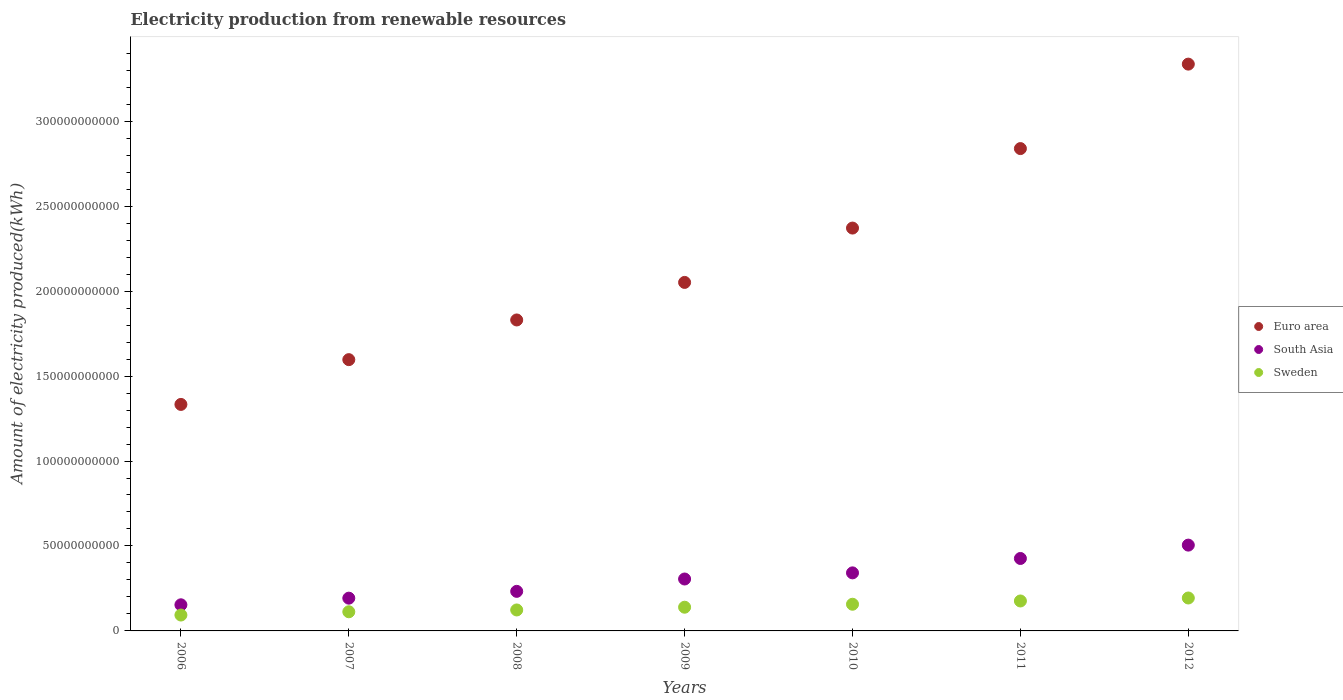How many different coloured dotlines are there?
Your answer should be very brief. 3. What is the amount of electricity produced in Sweden in 2007?
Keep it short and to the point. 1.13e+1. Across all years, what is the maximum amount of electricity produced in Sweden?
Your response must be concise. 1.94e+1. Across all years, what is the minimum amount of electricity produced in Euro area?
Keep it short and to the point. 1.33e+11. In which year was the amount of electricity produced in Euro area maximum?
Make the answer very short. 2012. What is the total amount of electricity produced in Sweden in the graph?
Provide a short and direct response. 9.96e+1. What is the difference between the amount of electricity produced in Sweden in 2009 and that in 2012?
Provide a short and direct response. -5.43e+09. What is the difference between the amount of electricity produced in South Asia in 2006 and the amount of electricity produced in Sweden in 2012?
Offer a very short reply. -4.00e+09. What is the average amount of electricity produced in Euro area per year?
Your answer should be very brief. 2.19e+11. In the year 2008, what is the difference between the amount of electricity produced in Euro area and amount of electricity produced in South Asia?
Offer a very short reply. 1.60e+11. In how many years, is the amount of electricity produced in Sweden greater than 30000000000 kWh?
Keep it short and to the point. 0. What is the ratio of the amount of electricity produced in South Asia in 2011 to that in 2012?
Offer a terse response. 0.84. Is the amount of electricity produced in South Asia in 2006 less than that in 2010?
Offer a very short reply. Yes. Is the difference between the amount of electricity produced in Euro area in 2008 and 2012 greater than the difference between the amount of electricity produced in South Asia in 2008 and 2012?
Keep it short and to the point. No. What is the difference between the highest and the second highest amount of electricity produced in Sweden?
Your answer should be very brief. 1.75e+09. What is the difference between the highest and the lowest amount of electricity produced in Euro area?
Provide a succinct answer. 2.00e+11. Is the sum of the amount of electricity produced in South Asia in 2010 and 2011 greater than the maximum amount of electricity produced in Euro area across all years?
Your answer should be compact. No. Is the amount of electricity produced in Sweden strictly less than the amount of electricity produced in South Asia over the years?
Ensure brevity in your answer.  Yes. How many years are there in the graph?
Your answer should be very brief. 7. What is the title of the graph?
Give a very brief answer. Electricity production from renewable resources. What is the label or title of the X-axis?
Your answer should be compact. Years. What is the label or title of the Y-axis?
Ensure brevity in your answer.  Amount of electricity produced(kWh). What is the Amount of electricity produced(kWh) of Euro area in 2006?
Give a very brief answer. 1.33e+11. What is the Amount of electricity produced(kWh) in South Asia in 2006?
Provide a succinct answer. 1.54e+1. What is the Amount of electricity produced(kWh) in Sweden in 2006?
Offer a terse response. 9.35e+09. What is the Amount of electricity produced(kWh) of Euro area in 2007?
Ensure brevity in your answer.  1.60e+11. What is the Amount of electricity produced(kWh) of South Asia in 2007?
Provide a succinct answer. 1.93e+1. What is the Amount of electricity produced(kWh) of Sweden in 2007?
Your answer should be compact. 1.13e+1. What is the Amount of electricity produced(kWh) of Euro area in 2008?
Ensure brevity in your answer.  1.83e+11. What is the Amount of electricity produced(kWh) of South Asia in 2008?
Make the answer very short. 2.33e+1. What is the Amount of electricity produced(kWh) in Sweden in 2008?
Keep it short and to the point. 1.23e+1. What is the Amount of electricity produced(kWh) of Euro area in 2009?
Ensure brevity in your answer.  2.05e+11. What is the Amount of electricity produced(kWh) of South Asia in 2009?
Give a very brief answer. 3.06e+1. What is the Amount of electricity produced(kWh) of Sweden in 2009?
Your answer should be very brief. 1.40e+1. What is the Amount of electricity produced(kWh) in Euro area in 2010?
Your response must be concise. 2.37e+11. What is the Amount of electricity produced(kWh) of South Asia in 2010?
Provide a succinct answer. 3.42e+1. What is the Amount of electricity produced(kWh) in Sweden in 2010?
Provide a short and direct response. 1.57e+1. What is the Amount of electricity produced(kWh) in Euro area in 2011?
Give a very brief answer. 2.84e+11. What is the Amount of electricity produced(kWh) in South Asia in 2011?
Offer a terse response. 4.26e+1. What is the Amount of electricity produced(kWh) of Sweden in 2011?
Give a very brief answer. 1.76e+1. What is the Amount of electricity produced(kWh) of Euro area in 2012?
Offer a terse response. 3.34e+11. What is the Amount of electricity produced(kWh) in South Asia in 2012?
Your answer should be very brief. 5.05e+1. What is the Amount of electricity produced(kWh) of Sweden in 2012?
Your response must be concise. 1.94e+1. Across all years, what is the maximum Amount of electricity produced(kWh) of Euro area?
Provide a short and direct response. 3.34e+11. Across all years, what is the maximum Amount of electricity produced(kWh) of South Asia?
Ensure brevity in your answer.  5.05e+1. Across all years, what is the maximum Amount of electricity produced(kWh) in Sweden?
Your response must be concise. 1.94e+1. Across all years, what is the minimum Amount of electricity produced(kWh) of Euro area?
Your response must be concise. 1.33e+11. Across all years, what is the minimum Amount of electricity produced(kWh) of South Asia?
Provide a succinct answer. 1.54e+1. Across all years, what is the minimum Amount of electricity produced(kWh) in Sweden?
Offer a terse response. 9.35e+09. What is the total Amount of electricity produced(kWh) of Euro area in the graph?
Your answer should be very brief. 1.54e+12. What is the total Amount of electricity produced(kWh) in South Asia in the graph?
Offer a terse response. 2.16e+11. What is the total Amount of electricity produced(kWh) in Sweden in the graph?
Provide a succinct answer. 9.96e+1. What is the difference between the Amount of electricity produced(kWh) in Euro area in 2006 and that in 2007?
Provide a succinct answer. -2.64e+1. What is the difference between the Amount of electricity produced(kWh) of South Asia in 2006 and that in 2007?
Make the answer very short. -3.90e+09. What is the difference between the Amount of electricity produced(kWh) of Sweden in 2006 and that in 2007?
Your answer should be very brief. -1.92e+09. What is the difference between the Amount of electricity produced(kWh) of Euro area in 2006 and that in 2008?
Offer a terse response. -4.97e+1. What is the difference between the Amount of electricity produced(kWh) in South Asia in 2006 and that in 2008?
Give a very brief answer. -7.91e+09. What is the difference between the Amount of electricity produced(kWh) of Sweden in 2006 and that in 2008?
Offer a very short reply. -2.99e+09. What is the difference between the Amount of electricity produced(kWh) in Euro area in 2006 and that in 2009?
Offer a terse response. -7.18e+1. What is the difference between the Amount of electricity produced(kWh) of South Asia in 2006 and that in 2009?
Offer a very short reply. -1.52e+1. What is the difference between the Amount of electricity produced(kWh) in Sweden in 2006 and that in 2009?
Make the answer very short. -4.60e+09. What is the difference between the Amount of electricity produced(kWh) of Euro area in 2006 and that in 2010?
Give a very brief answer. -1.04e+11. What is the difference between the Amount of electricity produced(kWh) of South Asia in 2006 and that in 2010?
Your answer should be very brief. -1.88e+1. What is the difference between the Amount of electricity produced(kWh) in Sweden in 2006 and that in 2010?
Keep it short and to the point. -6.36e+09. What is the difference between the Amount of electricity produced(kWh) of Euro area in 2006 and that in 2011?
Keep it short and to the point. -1.51e+11. What is the difference between the Amount of electricity produced(kWh) of South Asia in 2006 and that in 2011?
Provide a short and direct response. -2.73e+1. What is the difference between the Amount of electricity produced(kWh) of Sweden in 2006 and that in 2011?
Your answer should be very brief. -8.28e+09. What is the difference between the Amount of electricity produced(kWh) of Euro area in 2006 and that in 2012?
Your answer should be compact. -2.00e+11. What is the difference between the Amount of electricity produced(kWh) of South Asia in 2006 and that in 2012?
Give a very brief answer. -3.51e+1. What is the difference between the Amount of electricity produced(kWh) of Sweden in 2006 and that in 2012?
Offer a very short reply. -1.00e+1. What is the difference between the Amount of electricity produced(kWh) of Euro area in 2007 and that in 2008?
Offer a very short reply. -2.34e+1. What is the difference between the Amount of electricity produced(kWh) in South Asia in 2007 and that in 2008?
Make the answer very short. -4.01e+09. What is the difference between the Amount of electricity produced(kWh) in Sweden in 2007 and that in 2008?
Your answer should be very brief. -1.07e+09. What is the difference between the Amount of electricity produced(kWh) of Euro area in 2007 and that in 2009?
Your answer should be compact. -4.55e+1. What is the difference between the Amount of electricity produced(kWh) of South Asia in 2007 and that in 2009?
Make the answer very short. -1.13e+1. What is the difference between the Amount of electricity produced(kWh) of Sweden in 2007 and that in 2009?
Give a very brief answer. -2.68e+09. What is the difference between the Amount of electricity produced(kWh) of Euro area in 2007 and that in 2010?
Keep it short and to the point. -7.74e+1. What is the difference between the Amount of electricity produced(kWh) in South Asia in 2007 and that in 2010?
Your response must be concise. -1.49e+1. What is the difference between the Amount of electricity produced(kWh) in Sweden in 2007 and that in 2010?
Offer a terse response. -4.43e+09. What is the difference between the Amount of electricity produced(kWh) of Euro area in 2007 and that in 2011?
Make the answer very short. -1.24e+11. What is the difference between the Amount of electricity produced(kWh) in South Asia in 2007 and that in 2011?
Ensure brevity in your answer.  -2.34e+1. What is the difference between the Amount of electricity produced(kWh) of Sweden in 2007 and that in 2011?
Give a very brief answer. -6.36e+09. What is the difference between the Amount of electricity produced(kWh) of Euro area in 2007 and that in 2012?
Ensure brevity in your answer.  -1.74e+11. What is the difference between the Amount of electricity produced(kWh) of South Asia in 2007 and that in 2012?
Provide a succinct answer. -3.12e+1. What is the difference between the Amount of electricity produced(kWh) of Sweden in 2007 and that in 2012?
Make the answer very short. -8.11e+09. What is the difference between the Amount of electricity produced(kWh) in Euro area in 2008 and that in 2009?
Your answer should be very brief. -2.21e+1. What is the difference between the Amount of electricity produced(kWh) of South Asia in 2008 and that in 2009?
Ensure brevity in your answer.  -7.27e+09. What is the difference between the Amount of electricity produced(kWh) of Sweden in 2008 and that in 2009?
Ensure brevity in your answer.  -1.62e+09. What is the difference between the Amount of electricity produced(kWh) in Euro area in 2008 and that in 2010?
Offer a very short reply. -5.41e+1. What is the difference between the Amount of electricity produced(kWh) in South Asia in 2008 and that in 2010?
Ensure brevity in your answer.  -1.09e+1. What is the difference between the Amount of electricity produced(kWh) in Sweden in 2008 and that in 2010?
Make the answer very short. -3.37e+09. What is the difference between the Amount of electricity produced(kWh) of Euro area in 2008 and that in 2011?
Offer a very short reply. -1.01e+11. What is the difference between the Amount of electricity produced(kWh) in South Asia in 2008 and that in 2011?
Your answer should be very brief. -1.94e+1. What is the difference between the Amount of electricity produced(kWh) of Sweden in 2008 and that in 2011?
Offer a terse response. -5.29e+09. What is the difference between the Amount of electricity produced(kWh) in Euro area in 2008 and that in 2012?
Make the answer very short. -1.51e+11. What is the difference between the Amount of electricity produced(kWh) in South Asia in 2008 and that in 2012?
Give a very brief answer. -2.72e+1. What is the difference between the Amount of electricity produced(kWh) of Sweden in 2008 and that in 2012?
Provide a succinct answer. -7.04e+09. What is the difference between the Amount of electricity produced(kWh) of Euro area in 2009 and that in 2010?
Provide a short and direct response. -3.20e+1. What is the difference between the Amount of electricity produced(kWh) of South Asia in 2009 and that in 2010?
Provide a succinct answer. -3.61e+09. What is the difference between the Amount of electricity produced(kWh) of Sweden in 2009 and that in 2010?
Offer a very short reply. -1.75e+09. What is the difference between the Amount of electricity produced(kWh) in Euro area in 2009 and that in 2011?
Ensure brevity in your answer.  -7.88e+1. What is the difference between the Amount of electricity produced(kWh) of South Asia in 2009 and that in 2011?
Make the answer very short. -1.21e+1. What is the difference between the Amount of electricity produced(kWh) in Sweden in 2009 and that in 2011?
Make the answer very short. -3.67e+09. What is the difference between the Amount of electricity produced(kWh) in Euro area in 2009 and that in 2012?
Provide a succinct answer. -1.28e+11. What is the difference between the Amount of electricity produced(kWh) of South Asia in 2009 and that in 2012?
Your response must be concise. -1.99e+1. What is the difference between the Amount of electricity produced(kWh) of Sweden in 2009 and that in 2012?
Your answer should be very brief. -5.43e+09. What is the difference between the Amount of electricity produced(kWh) in Euro area in 2010 and that in 2011?
Your answer should be compact. -4.68e+1. What is the difference between the Amount of electricity produced(kWh) in South Asia in 2010 and that in 2011?
Offer a terse response. -8.47e+09. What is the difference between the Amount of electricity produced(kWh) in Sweden in 2010 and that in 2011?
Give a very brief answer. -1.92e+09. What is the difference between the Amount of electricity produced(kWh) in Euro area in 2010 and that in 2012?
Ensure brevity in your answer.  -9.65e+1. What is the difference between the Amount of electricity produced(kWh) of South Asia in 2010 and that in 2012?
Provide a succinct answer. -1.63e+1. What is the difference between the Amount of electricity produced(kWh) in Sweden in 2010 and that in 2012?
Offer a very short reply. -3.68e+09. What is the difference between the Amount of electricity produced(kWh) in Euro area in 2011 and that in 2012?
Your response must be concise. -4.97e+1. What is the difference between the Amount of electricity produced(kWh) of South Asia in 2011 and that in 2012?
Keep it short and to the point. -7.86e+09. What is the difference between the Amount of electricity produced(kWh) of Sweden in 2011 and that in 2012?
Offer a terse response. -1.75e+09. What is the difference between the Amount of electricity produced(kWh) in Euro area in 2006 and the Amount of electricity produced(kWh) in South Asia in 2007?
Provide a short and direct response. 1.14e+11. What is the difference between the Amount of electricity produced(kWh) in Euro area in 2006 and the Amount of electricity produced(kWh) in Sweden in 2007?
Your answer should be compact. 1.22e+11. What is the difference between the Amount of electricity produced(kWh) of South Asia in 2006 and the Amount of electricity produced(kWh) of Sweden in 2007?
Provide a succinct answer. 4.10e+09. What is the difference between the Amount of electricity produced(kWh) of Euro area in 2006 and the Amount of electricity produced(kWh) of South Asia in 2008?
Make the answer very short. 1.10e+11. What is the difference between the Amount of electricity produced(kWh) in Euro area in 2006 and the Amount of electricity produced(kWh) in Sweden in 2008?
Provide a short and direct response. 1.21e+11. What is the difference between the Amount of electricity produced(kWh) in South Asia in 2006 and the Amount of electricity produced(kWh) in Sweden in 2008?
Your answer should be very brief. 3.04e+09. What is the difference between the Amount of electricity produced(kWh) in Euro area in 2006 and the Amount of electricity produced(kWh) in South Asia in 2009?
Offer a very short reply. 1.03e+11. What is the difference between the Amount of electricity produced(kWh) of Euro area in 2006 and the Amount of electricity produced(kWh) of Sweden in 2009?
Your answer should be compact. 1.19e+11. What is the difference between the Amount of electricity produced(kWh) of South Asia in 2006 and the Amount of electricity produced(kWh) of Sweden in 2009?
Ensure brevity in your answer.  1.42e+09. What is the difference between the Amount of electricity produced(kWh) of Euro area in 2006 and the Amount of electricity produced(kWh) of South Asia in 2010?
Keep it short and to the point. 9.91e+1. What is the difference between the Amount of electricity produced(kWh) in Euro area in 2006 and the Amount of electricity produced(kWh) in Sweden in 2010?
Your answer should be compact. 1.18e+11. What is the difference between the Amount of electricity produced(kWh) of South Asia in 2006 and the Amount of electricity produced(kWh) of Sweden in 2010?
Your response must be concise. -3.29e+08. What is the difference between the Amount of electricity produced(kWh) of Euro area in 2006 and the Amount of electricity produced(kWh) of South Asia in 2011?
Your answer should be compact. 9.07e+1. What is the difference between the Amount of electricity produced(kWh) of Euro area in 2006 and the Amount of electricity produced(kWh) of Sweden in 2011?
Offer a terse response. 1.16e+11. What is the difference between the Amount of electricity produced(kWh) in South Asia in 2006 and the Amount of electricity produced(kWh) in Sweden in 2011?
Give a very brief answer. -2.25e+09. What is the difference between the Amount of electricity produced(kWh) in Euro area in 2006 and the Amount of electricity produced(kWh) in South Asia in 2012?
Offer a terse response. 8.28e+1. What is the difference between the Amount of electricity produced(kWh) in Euro area in 2006 and the Amount of electricity produced(kWh) in Sweden in 2012?
Give a very brief answer. 1.14e+11. What is the difference between the Amount of electricity produced(kWh) in South Asia in 2006 and the Amount of electricity produced(kWh) in Sweden in 2012?
Your answer should be compact. -4.00e+09. What is the difference between the Amount of electricity produced(kWh) of Euro area in 2007 and the Amount of electricity produced(kWh) of South Asia in 2008?
Ensure brevity in your answer.  1.36e+11. What is the difference between the Amount of electricity produced(kWh) in Euro area in 2007 and the Amount of electricity produced(kWh) in Sweden in 2008?
Give a very brief answer. 1.47e+11. What is the difference between the Amount of electricity produced(kWh) in South Asia in 2007 and the Amount of electricity produced(kWh) in Sweden in 2008?
Provide a short and direct response. 6.94e+09. What is the difference between the Amount of electricity produced(kWh) in Euro area in 2007 and the Amount of electricity produced(kWh) in South Asia in 2009?
Provide a short and direct response. 1.29e+11. What is the difference between the Amount of electricity produced(kWh) in Euro area in 2007 and the Amount of electricity produced(kWh) in Sweden in 2009?
Offer a very short reply. 1.46e+11. What is the difference between the Amount of electricity produced(kWh) of South Asia in 2007 and the Amount of electricity produced(kWh) of Sweden in 2009?
Provide a short and direct response. 5.33e+09. What is the difference between the Amount of electricity produced(kWh) in Euro area in 2007 and the Amount of electricity produced(kWh) in South Asia in 2010?
Keep it short and to the point. 1.25e+11. What is the difference between the Amount of electricity produced(kWh) of Euro area in 2007 and the Amount of electricity produced(kWh) of Sweden in 2010?
Provide a short and direct response. 1.44e+11. What is the difference between the Amount of electricity produced(kWh) in South Asia in 2007 and the Amount of electricity produced(kWh) in Sweden in 2010?
Provide a succinct answer. 3.58e+09. What is the difference between the Amount of electricity produced(kWh) of Euro area in 2007 and the Amount of electricity produced(kWh) of South Asia in 2011?
Provide a short and direct response. 1.17e+11. What is the difference between the Amount of electricity produced(kWh) of Euro area in 2007 and the Amount of electricity produced(kWh) of Sweden in 2011?
Ensure brevity in your answer.  1.42e+11. What is the difference between the Amount of electricity produced(kWh) of South Asia in 2007 and the Amount of electricity produced(kWh) of Sweden in 2011?
Give a very brief answer. 1.65e+09. What is the difference between the Amount of electricity produced(kWh) of Euro area in 2007 and the Amount of electricity produced(kWh) of South Asia in 2012?
Offer a very short reply. 1.09e+11. What is the difference between the Amount of electricity produced(kWh) of Euro area in 2007 and the Amount of electricity produced(kWh) of Sweden in 2012?
Give a very brief answer. 1.40e+11. What is the difference between the Amount of electricity produced(kWh) in South Asia in 2007 and the Amount of electricity produced(kWh) in Sweden in 2012?
Make the answer very short. -1.00e+08. What is the difference between the Amount of electricity produced(kWh) of Euro area in 2008 and the Amount of electricity produced(kWh) of South Asia in 2009?
Offer a very short reply. 1.52e+11. What is the difference between the Amount of electricity produced(kWh) of Euro area in 2008 and the Amount of electricity produced(kWh) of Sweden in 2009?
Give a very brief answer. 1.69e+11. What is the difference between the Amount of electricity produced(kWh) in South Asia in 2008 and the Amount of electricity produced(kWh) in Sweden in 2009?
Provide a short and direct response. 9.33e+09. What is the difference between the Amount of electricity produced(kWh) of Euro area in 2008 and the Amount of electricity produced(kWh) of South Asia in 2010?
Keep it short and to the point. 1.49e+11. What is the difference between the Amount of electricity produced(kWh) in Euro area in 2008 and the Amount of electricity produced(kWh) in Sweden in 2010?
Keep it short and to the point. 1.67e+11. What is the difference between the Amount of electricity produced(kWh) of South Asia in 2008 and the Amount of electricity produced(kWh) of Sweden in 2010?
Your answer should be compact. 7.58e+09. What is the difference between the Amount of electricity produced(kWh) in Euro area in 2008 and the Amount of electricity produced(kWh) in South Asia in 2011?
Provide a succinct answer. 1.40e+11. What is the difference between the Amount of electricity produced(kWh) in Euro area in 2008 and the Amount of electricity produced(kWh) in Sweden in 2011?
Ensure brevity in your answer.  1.65e+11. What is the difference between the Amount of electricity produced(kWh) in South Asia in 2008 and the Amount of electricity produced(kWh) in Sweden in 2011?
Make the answer very short. 5.66e+09. What is the difference between the Amount of electricity produced(kWh) of Euro area in 2008 and the Amount of electricity produced(kWh) of South Asia in 2012?
Keep it short and to the point. 1.33e+11. What is the difference between the Amount of electricity produced(kWh) in Euro area in 2008 and the Amount of electricity produced(kWh) in Sweden in 2012?
Keep it short and to the point. 1.64e+11. What is the difference between the Amount of electricity produced(kWh) of South Asia in 2008 and the Amount of electricity produced(kWh) of Sweden in 2012?
Give a very brief answer. 3.91e+09. What is the difference between the Amount of electricity produced(kWh) of Euro area in 2009 and the Amount of electricity produced(kWh) of South Asia in 2010?
Offer a very short reply. 1.71e+11. What is the difference between the Amount of electricity produced(kWh) in Euro area in 2009 and the Amount of electricity produced(kWh) in Sweden in 2010?
Provide a short and direct response. 1.89e+11. What is the difference between the Amount of electricity produced(kWh) in South Asia in 2009 and the Amount of electricity produced(kWh) in Sweden in 2010?
Make the answer very short. 1.49e+1. What is the difference between the Amount of electricity produced(kWh) in Euro area in 2009 and the Amount of electricity produced(kWh) in South Asia in 2011?
Give a very brief answer. 1.62e+11. What is the difference between the Amount of electricity produced(kWh) in Euro area in 2009 and the Amount of electricity produced(kWh) in Sweden in 2011?
Provide a succinct answer. 1.87e+11. What is the difference between the Amount of electricity produced(kWh) of South Asia in 2009 and the Amount of electricity produced(kWh) of Sweden in 2011?
Ensure brevity in your answer.  1.29e+1. What is the difference between the Amount of electricity produced(kWh) of Euro area in 2009 and the Amount of electricity produced(kWh) of South Asia in 2012?
Provide a short and direct response. 1.55e+11. What is the difference between the Amount of electricity produced(kWh) in Euro area in 2009 and the Amount of electricity produced(kWh) in Sweden in 2012?
Your answer should be compact. 1.86e+11. What is the difference between the Amount of electricity produced(kWh) of South Asia in 2009 and the Amount of electricity produced(kWh) of Sweden in 2012?
Offer a very short reply. 1.12e+1. What is the difference between the Amount of electricity produced(kWh) of Euro area in 2010 and the Amount of electricity produced(kWh) of South Asia in 2011?
Ensure brevity in your answer.  1.94e+11. What is the difference between the Amount of electricity produced(kWh) in Euro area in 2010 and the Amount of electricity produced(kWh) in Sweden in 2011?
Make the answer very short. 2.19e+11. What is the difference between the Amount of electricity produced(kWh) of South Asia in 2010 and the Amount of electricity produced(kWh) of Sweden in 2011?
Your response must be concise. 1.65e+1. What is the difference between the Amount of electricity produced(kWh) of Euro area in 2010 and the Amount of electricity produced(kWh) of South Asia in 2012?
Your response must be concise. 1.87e+11. What is the difference between the Amount of electricity produced(kWh) in Euro area in 2010 and the Amount of electricity produced(kWh) in Sweden in 2012?
Offer a terse response. 2.18e+11. What is the difference between the Amount of electricity produced(kWh) in South Asia in 2010 and the Amount of electricity produced(kWh) in Sweden in 2012?
Offer a very short reply. 1.48e+1. What is the difference between the Amount of electricity produced(kWh) of Euro area in 2011 and the Amount of electricity produced(kWh) of South Asia in 2012?
Offer a terse response. 2.33e+11. What is the difference between the Amount of electricity produced(kWh) in Euro area in 2011 and the Amount of electricity produced(kWh) in Sweden in 2012?
Your response must be concise. 2.65e+11. What is the difference between the Amount of electricity produced(kWh) in South Asia in 2011 and the Amount of electricity produced(kWh) in Sweden in 2012?
Your answer should be compact. 2.33e+1. What is the average Amount of electricity produced(kWh) of Euro area per year?
Your response must be concise. 2.19e+11. What is the average Amount of electricity produced(kWh) in South Asia per year?
Offer a terse response. 3.08e+1. What is the average Amount of electricity produced(kWh) in Sweden per year?
Offer a terse response. 1.42e+1. In the year 2006, what is the difference between the Amount of electricity produced(kWh) of Euro area and Amount of electricity produced(kWh) of South Asia?
Ensure brevity in your answer.  1.18e+11. In the year 2006, what is the difference between the Amount of electricity produced(kWh) of Euro area and Amount of electricity produced(kWh) of Sweden?
Make the answer very short. 1.24e+11. In the year 2006, what is the difference between the Amount of electricity produced(kWh) of South Asia and Amount of electricity produced(kWh) of Sweden?
Make the answer very short. 6.03e+09. In the year 2007, what is the difference between the Amount of electricity produced(kWh) in Euro area and Amount of electricity produced(kWh) in South Asia?
Offer a terse response. 1.40e+11. In the year 2007, what is the difference between the Amount of electricity produced(kWh) of Euro area and Amount of electricity produced(kWh) of Sweden?
Provide a succinct answer. 1.48e+11. In the year 2007, what is the difference between the Amount of electricity produced(kWh) of South Asia and Amount of electricity produced(kWh) of Sweden?
Ensure brevity in your answer.  8.01e+09. In the year 2008, what is the difference between the Amount of electricity produced(kWh) of Euro area and Amount of electricity produced(kWh) of South Asia?
Offer a very short reply. 1.60e+11. In the year 2008, what is the difference between the Amount of electricity produced(kWh) of Euro area and Amount of electricity produced(kWh) of Sweden?
Your answer should be compact. 1.71e+11. In the year 2008, what is the difference between the Amount of electricity produced(kWh) in South Asia and Amount of electricity produced(kWh) in Sweden?
Your answer should be very brief. 1.09e+1. In the year 2009, what is the difference between the Amount of electricity produced(kWh) of Euro area and Amount of electricity produced(kWh) of South Asia?
Give a very brief answer. 1.75e+11. In the year 2009, what is the difference between the Amount of electricity produced(kWh) in Euro area and Amount of electricity produced(kWh) in Sweden?
Offer a terse response. 1.91e+11. In the year 2009, what is the difference between the Amount of electricity produced(kWh) in South Asia and Amount of electricity produced(kWh) in Sweden?
Offer a very short reply. 1.66e+1. In the year 2010, what is the difference between the Amount of electricity produced(kWh) of Euro area and Amount of electricity produced(kWh) of South Asia?
Your answer should be very brief. 2.03e+11. In the year 2010, what is the difference between the Amount of electricity produced(kWh) in Euro area and Amount of electricity produced(kWh) in Sweden?
Make the answer very short. 2.21e+11. In the year 2010, what is the difference between the Amount of electricity produced(kWh) of South Asia and Amount of electricity produced(kWh) of Sweden?
Offer a very short reply. 1.85e+1. In the year 2011, what is the difference between the Amount of electricity produced(kWh) of Euro area and Amount of electricity produced(kWh) of South Asia?
Ensure brevity in your answer.  2.41e+11. In the year 2011, what is the difference between the Amount of electricity produced(kWh) in Euro area and Amount of electricity produced(kWh) in Sweden?
Keep it short and to the point. 2.66e+11. In the year 2011, what is the difference between the Amount of electricity produced(kWh) of South Asia and Amount of electricity produced(kWh) of Sweden?
Keep it short and to the point. 2.50e+1. In the year 2012, what is the difference between the Amount of electricity produced(kWh) of Euro area and Amount of electricity produced(kWh) of South Asia?
Offer a very short reply. 2.83e+11. In the year 2012, what is the difference between the Amount of electricity produced(kWh) of Euro area and Amount of electricity produced(kWh) of Sweden?
Keep it short and to the point. 3.14e+11. In the year 2012, what is the difference between the Amount of electricity produced(kWh) in South Asia and Amount of electricity produced(kWh) in Sweden?
Offer a very short reply. 3.11e+1. What is the ratio of the Amount of electricity produced(kWh) in Euro area in 2006 to that in 2007?
Keep it short and to the point. 0.83. What is the ratio of the Amount of electricity produced(kWh) of South Asia in 2006 to that in 2007?
Your response must be concise. 0.8. What is the ratio of the Amount of electricity produced(kWh) of Sweden in 2006 to that in 2007?
Give a very brief answer. 0.83. What is the ratio of the Amount of electricity produced(kWh) of Euro area in 2006 to that in 2008?
Ensure brevity in your answer.  0.73. What is the ratio of the Amount of electricity produced(kWh) in South Asia in 2006 to that in 2008?
Ensure brevity in your answer.  0.66. What is the ratio of the Amount of electricity produced(kWh) in Sweden in 2006 to that in 2008?
Your answer should be very brief. 0.76. What is the ratio of the Amount of electricity produced(kWh) in Euro area in 2006 to that in 2009?
Ensure brevity in your answer.  0.65. What is the ratio of the Amount of electricity produced(kWh) in South Asia in 2006 to that in 2009?
Give a very brief answer. 0.5. What is the ratio of the Amount of electricity produced(kWh) in Sweden in 2006 to that in 2009?
Ensure brevity in your answer.  0.67. What is the ratio of the Amount of electricity produced(kWh) of Euro area in 2006 to that in 2010?
Keep it short and to the point. 0.56. What is the ratio of the Amount of electricity produced(kWh) in South Asia in 2006 to that in 2010?
Your response must be concise. 0.45. What is the ratio of the Amount of electricity produced(kWh) in Sweden in 2006 to that in 2010?
Ensure brevity in your answer.  0.6. What is the ratio of the Amount of electricity produced(kWh) of Euro area in 2006 to that in 2011?
Ensure brevity in your answer.  0.47. What is the ratio of the Amount of electricity produced(kWh) in South Asia in 2006 to that in 2011?
Provide a short and direct response. 0.36. What is the ratio of the Amount of electricity produced(kWh) of Sweden in 2006 to that in 2011?
Provide a succinct answer. 0.53. What is the ratio of the Amount of electricity produced(kWh) of Euro area in 2006 to that in 2012?
Provide a short and direct response. 0.4. What is the ratio of the Amount of electricity produced(kWh) of South Asia in 2006 to that in 2012?
Offer a very short reply. 0.3. What is the ratio of the Amount of electricity produced(kWh) in Sweden in 2006 to that in 2012?
Provide a succinct answer. 0.48. What is the ratio of the Amount of electricity produced(kWh) in Euro area in 2007 to that in 2008?
Give a very brief answer. 0.87. What is the ratio of the Amount of electricity produced(kWh) of South Asia in 2007 to that in 2008?
Ensure brevity in your answer.  0.83. What is the ratio of the Amount of electricity produced(kWh) in Sweden in 2007 to that in 2008?
Keep it short and to the point. 0.91. What is the ratio of the Amount of electricity produced(kWh) of Euro area in 2007 to that in 2009?
Provide a short and direct response. 0.78. What is the ratio of the Amount of electricity produced(kWh) in South Asia in 2007 to that in 2009?
Offer a very short reply. 0.63. What is the ratio of the Amount of electricity produced(kWh) of Sweden in 2007 to that in 2009?
Offer a terse response. 0.81. What is the ratio of the Amount of electricity produced(kWh) of Euro area in 2007 to that in 2010?
Provide a succinct answer. 0.67. What is the ratio of the Amount of electricity produced(kWh) of South Asia in 2007 to that in 2010?
Your answer should be very brief. 0.56. What is the ratio of the Amount of electricity produced(kWh) of Sweden in 2007 to that in 2010?
Give a very brief answer. 0.72. What is the ratio of the Amount of electricity produced(kWh) of Euro area in 2007 to that in 2011?
Provide a short and direct response. 0.56. What is the ratio of the Amount of electricity produced(kWh) of South Asia in 2007 to that in 2011?
Keep it short and to the point. 0.45. What is the ratio of the Amount of electricity produced(kWh) of Sweden in 2007 to that in 2011?
Offer a very short reply. 0.64. What is the ratio of the Amount of electricity produced(kWh) in Euro area in 2007 to that in 2012?
Provide a succinct answer. 0.48. What is the ratio of the Amount of electricity produced(kWh) in South Asia in 2007 to that in 2012?
Keep it short and to the point. 0.38. What is the ratio of the Amount of electricity produced(kWh) of Sweden in 2007 to that in 2012?
Your answer should be very brief. 0.58. What is the ratio of the Amount of electricity produced(kWh) in Euro area in 2008 to that in 2009?
Your response must be concise. 0.89. What is the ratio of the Amount of electricity produced(kWh) of South Asia in 2008 to that in 2009?
Ensure brevity in your answer.  0.76. What is the ratio of the Amount of electricity produced(kWh) in Sweden in 2008 to that in 2009?
Your answer should be compact. 0.88. What is the ratio of the Amount of electricity produced(kWh) in Euro area in 2008 to that in 2010?
Keep it short and to the point. 0.77. What is the ratio of the Amount of electricity produced(kWh) in South Asia in 2008 to that in 2010?
Give a very brief answer. 0.68. What is the ratio of the Amount of electricity produced(kWh) in Sweden in 2008 to that in 2010?
Make the answer very short. 0.79. What is the ratio of the Amount of electricity produced(kWh) of Euro area in 2008 to that in 2011?
Your response must be concise. 0.64. What is the ratio of the Amount of electricity produced(kWh) of South Asia in 2008 to that in 2011?
Provide a succinct answer. 0.55. What is the ratio of the Amount of electricity produced(kWh) of Sweden in 2008 to that in 2011?
Keep it short and to the point. 0.7. What is the ratio of the Amount of electricity produced(kWh) of Euro area in 2008 to that in 2012?
Give a very brief answer. 0.55. What is the ratio of the Amount of electricity produced(kWh) in South Asia in 2008 to that in 2012?
Offer a very short reply. 0.46. What is the ratio of the Amount of electricity produced(kWh) in Sweden in 2008 to that in 2012?
Offer a very short reply. 0.64. What is the ratio of the Amount of electricity produced(kWh) in Euro area in 2009 to that in 2010?
Keep it short and to the point. 0.87. What is the ratio of the Amount of electricity produced(kWh) in South Asia in 2009 to that in 2010?
Provide a succinct answer. 0.89. What is the ratio of the Amount of electricity produced(kWh) of Sweden in 2009 to that in 2010?
Ensure brevity in your answer.  0.89. What is the ratio of the Amount of electricity produced(kWh) in Euro area in 2009 to that in 2011?
Provide a succinct answer. 0.72. What is the ratio of the Amount of electricity produced(kWh) in South Asia in 2009 to that in 2011?
Provide a succinct answer. 0.72. What is the ratio of the Amount of electricity produced(kWh) of Sweden in 2009 to that in 2011?
Offer a terse response. 0.79. What is the ratio of the Amount of electricity produced(kWh) of Euro area in 2009 to that in 2012?
Your answer should be very brief. 0.61. What is the ratio of the Amount of electricity produced(kWh) of South Asia in 2009 to that in 2012?
Your response must be concise. 0.61. What is the ratio of the Amount of electricity produced(kWh) of Sweden in 2009 to that in 2012?
Keep it short and to the point. 0.72. What is the ratio of the Amount of electricity produced(kWh) of Euro area in 2010 to that in 2011?
Your answer should be very brief. 0.84. What is the ratio of the Amount of electricity produced(kWh) in South Asia in 2010 to that in 2011?
Provide a succinct answer. 0.8. What is the ratio of the Amount of electricity produced(kWh) in Sweden in 2010 to that in 2011?
Give a very brief answer. 0.89. What is the ratio of the Amount of electricity produced(kWh) of Euro area in 2010 to that in 2012?
Offer a very short reply. 0.71. What is the ratio of the Amount of electricity produced(kWh) in South Asia in 2010 to that in 2012?
Make the answer very short. 0.68. What is the ratio of the Amount of electricity produced(kWh) in Sweden in 2010 to that in 2012?
Ensure brevity in your answer.  0.81. What is the ratio of the Amount of electricity produced(kWh) in Euro area in 2011 to that in 2012?
Keep it short and to the point. 0.85. What is the ratio of the Amount of electricity produced(kWh) in South Asia in 2011 to that in 2012?
Offer a very short reply. 0.84. What is the ratio of the Amount of electricity produced(kWh) in Sweden in 2011 to that in 2012?
Ensure brevity in your answer.  0.91. What is the difference between the highest and the second highest Amount of electricity produced(kWh) of Euro area?
Offer a very short reply. 4.97e+1. What is the difference between the highest and the second highest Amount of electricity produced(kWh) in South Asia?
Give a very brief answer. 7.86e+09. What is the difference between the highest and the second highest Amount of electricity produced(kWh) of Sweden?
Provide a short and direct response. 1.75e+09. What is the difference between the highest and the lowest Amount of electricity produced(kWh) of Euro area?
Your answer should be compact. 2.00e+11. What is the difference between the highest and the lowest Amount of electricity produced(kWh) of South Asia?
Keep it short and to the point. 3.51e+1. What is the difference between the highest and the lowest Amount of electricity produced(kWh) of Sweden?
Your response must be concise. 1.00e+1. 